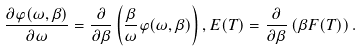Convert formula to latex. <formula><loc_0><loc_0><loc_500><loc_500>\frac { \partial \varphi ( \omega , \beta ) } { \partial \omega } = \frac { \partial } { \partial \beta } \left ( \frac { \beta } { \omega } \varphi ( \omega , \beta ) \right ) , E ( T ) = \frac { \partial } { \partial \beta } \left ( \beta F ( T ) \right ) .</formula> 